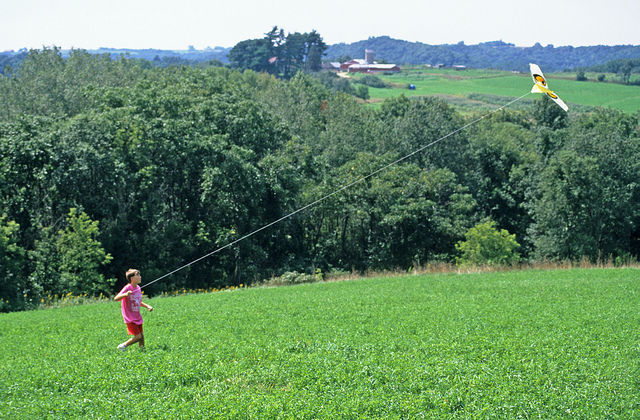Can you tell me more about the kid's surroundings for flying the kite? The child is surrounded by a lush green hill, providing a soft and open space ideal for running and flying a kite. The surrounding trees add to the picturesque view, where nature is in abundance, giving a refreshing and tranquil atmosphere. The distant view of the town shows a peaceful countryside with rolling meadows and farmlands. 